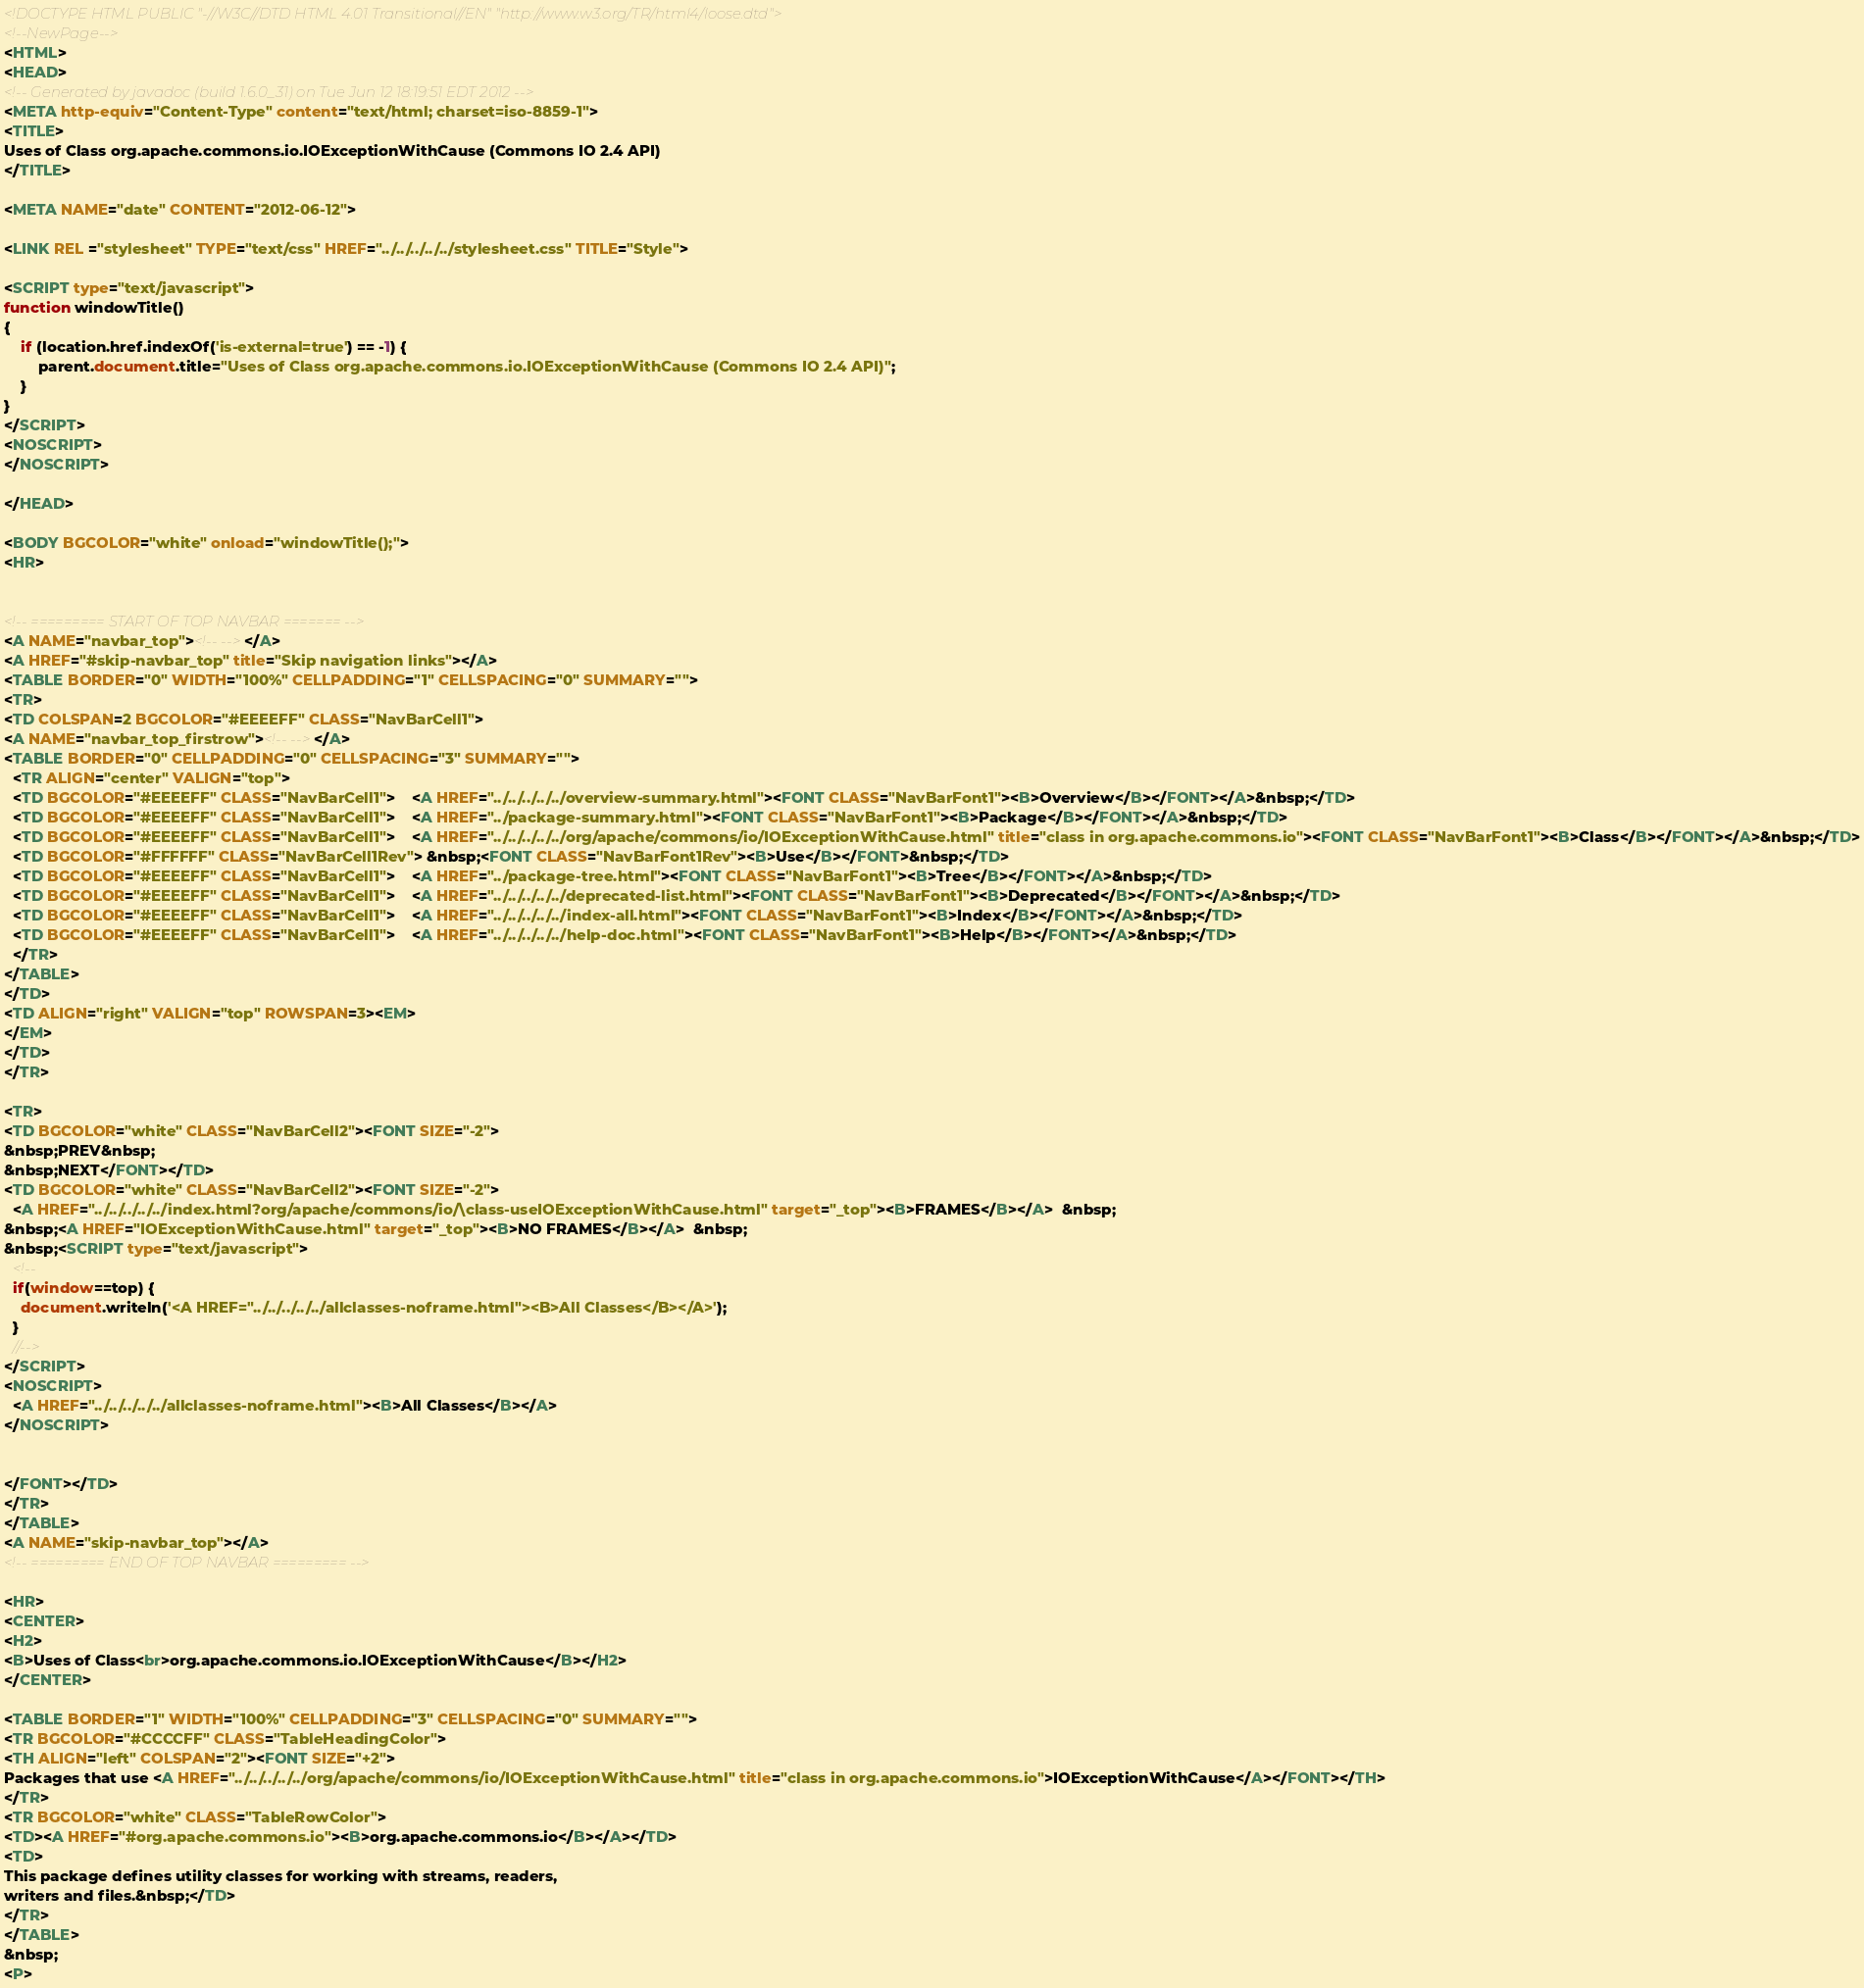<code> <loc_0><loc_0><loc_500><loc_500><_HTML_><!DOCTYPE HTML PUBLIC "-//W3C//DTD HTML 4.01 Transitional//EN" "http://www.w3.org/TR/html4/loose.dtd">
<!--NewPage-->
<HTML>
<HEAD>
<!-- Generated by javadoc (build 1.6.0_31) on Tue Jun 12 18:19:51 EDT 2012 -->
<META http-equiv="Content-Type" content="text/html; charset=iso-8859-1">
<TITLE>
Uses of Class org.apache.commons.io.IOExceptionWithCause (Commons IO 2.4 API)
</TITLE>

<META NAME="date" CONTENT="2012-06-12">

<LINK REL ="stylesheet" TYPE="text/css" HREF="../../../../../stylesheet.css" TITLE="Style">

<SCRIPT type="text/javascript">
function windowTitle()
{
    if (location.href.indexOf('is-external=true') == -1) {
        parent.document.title="Uses of Class org.apache.commons.io.IOExceptionWithCause (Commons IO 2.4 API)";
    }
}
</SCRIPT>
<NOSCRIPT>
</NOSCRIPT>

</HEAD>

<BODY BGCOLOR="white" onload="windowTitle();">
<HR>


<!-- ========= START OF TOP NAVBAR ======= -->
<A NAME="navbar_top"><!-- --></A>
<A HREF="#skip-navbar_top" title="Skip navigation links"></A>
<TABLE BORDER="0" WIDTH="100%" CELLPADDING="1" CELLSPACING="0" SUMMARY="">
<TR>
<TD COLSPAN=2 BGCOLOR="#EEEEFF" CLASS="NavBarCell1">
<A NAME="navbar_top_firstrow"><!-- --></A>
<TABLE BORDER="0" CELLPADDING="0" CELLSPACING="3" SUMMARY="">
  <TR ALIGN="center" VALIGN="top">
  <TD BGCOLOR="#EEEEFF" CLASS="NavBarCell1">    <A HREF="../../../../../overview-summary.html"><FONT CLASS="NavBarFont1"><B>Overview</B></FONT></A>&nbsp;</TD>
  <TD BGCOLOR="#EEEEFF" CLASS="NavBarCell1">    <A HREF="../package-summary.html"><FONT CLASS="NavBarFont1"><B>Package</B></FONT></A>&nbsp;</TD>
  <TD BGCOLOR="#EEEEFF" CLASS="NavBarCell1">    <A HREF="../../../../../org/apache/commons/io/IOExceptionWithCause.html" title="class in org.apache.commons.io"><FONT CLASS="NavBarFont1"><B>Class</B></FONT></A>&nbsp;</TD>
  <TD BGCOLOR="#FFFFFF" CLASS="NavBarCell1Rev"> &nbsp;<FONT CLASS="NavBarFont1Rev"><B>Use</B></FONT>&nbsp;</TD>
  <TD BGCOLOR="#EEEEFF" CLASS="NavBarCell1">    <A HREF="../package-tree.html"><FONT CLASS="NavBarFont1"><B>Tree</B></FONT></A>&nbsp;</TD>
  <TD BGCOLOR="#EEEEFF" CLASS="NavBarCell1">    <A HREF="../../../../../deprecated-list.html"><FONT CLASS="NavBarFont1"><B>Deprecated</B></FONT></A>&nbsp;</TD>
  <TD BGCOLOR="#EEEEFF" CLASS="NavBarCell1">    <A HREF="../../../../../index-all.html"><FONT CLASS="NavBarFont1"><B>Index</B></FONT></A>&nbsp;</TD>
  <TD BGCOLOR="#EEEEFF" CLASS="NavBarCell1">    <A HREF="../../../../../help-doc.html"><FONT CLASS="NavBarFont1"><B>Help</B></FONT></A>&nbsp;</TD>
  </TR>
</TABLE>
</TD>
<TD ALIGN="right" VALIGN="top" ROWSPAN=3><EM>
</EM>
</TD>
</TR>

<TR>
<TD BGCOLOR="white" CLASS="NavBarCell2"><FONT SIZE="-2">
&nbsp;PREV&nbsp;
&nbsp;NEXT</FONT></TD>
<TD BGCOLOR="white" CLASS="NavBarCell2"><FONT SIZE="-2">
  <A HREF="../../../../../index.html?org/apache/commons/io/\class-useIOExceptionWithCause.html" target="_top"><B>FRAMES</B></A>  &nbsp;
&nbsp;<A HREF="IOExceptionWithCause.html" target="_top"><B>NO FRAMES</B></A>  &nbsp;
&nbsp;<SCRIPT type="text/javascript">
  <!--
  if(window==top) {
    document.writeln('<A HREF="../../../../../allclasses-noframe.html"><B>All Classes</B></A>');
  }
  //-->
</SCRIPT>
<NOSCRIPT>
  <A HREF="../../../../../allclasses-noframe.html"><B>All Classes</B></A>
</NOSCRIPT>


</FONT></TD>
</TR>
</TABLE>
<A NAME="skip-navbar_top"></A>
<!-- ========= END OF TOP NAVBAR ========= -->

<HR>
<CENTER>
<H2>
<B>Uses of Class<br>org.apache.commons.io.IOExceptionWithCause</B></H2>
</CENTER>

<TABLE BORDER="1" WIDTH="100%" CELLPADDING="3" CELLSPACING="0" SUMMARY="">
<TR BGCOLOR="#CCCCFF" CLASS="TableHeadingColor">
<TH ALIGN="left" COLSPAN="2"><FONT SIZE="+2">
Packages that use <A HREF="../../../../../org/apache/commons/io/IOExceptionWithCause.html" title="class in org.apache.commons.io">IOExceptionWithCause</A></FONT></TH>
</TR>
<TR BGCOLOR="white" CLASS="TableRowColor">
<TD><A HREF="#org.apache.commons.io"><B>org.apache.commons.io</B></A></TD>
<TD>
This package defines utility classes for working with streams, readers,
writers and files.&nbsp;</TD>
</TR>
</TABLE>
&nbsp;
<P></code> 